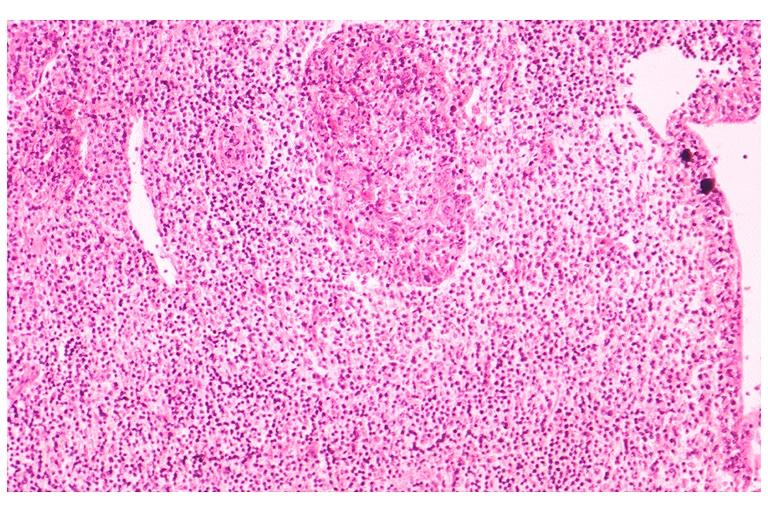s jejunum present?
Answer the question using a single word or phrase. No 